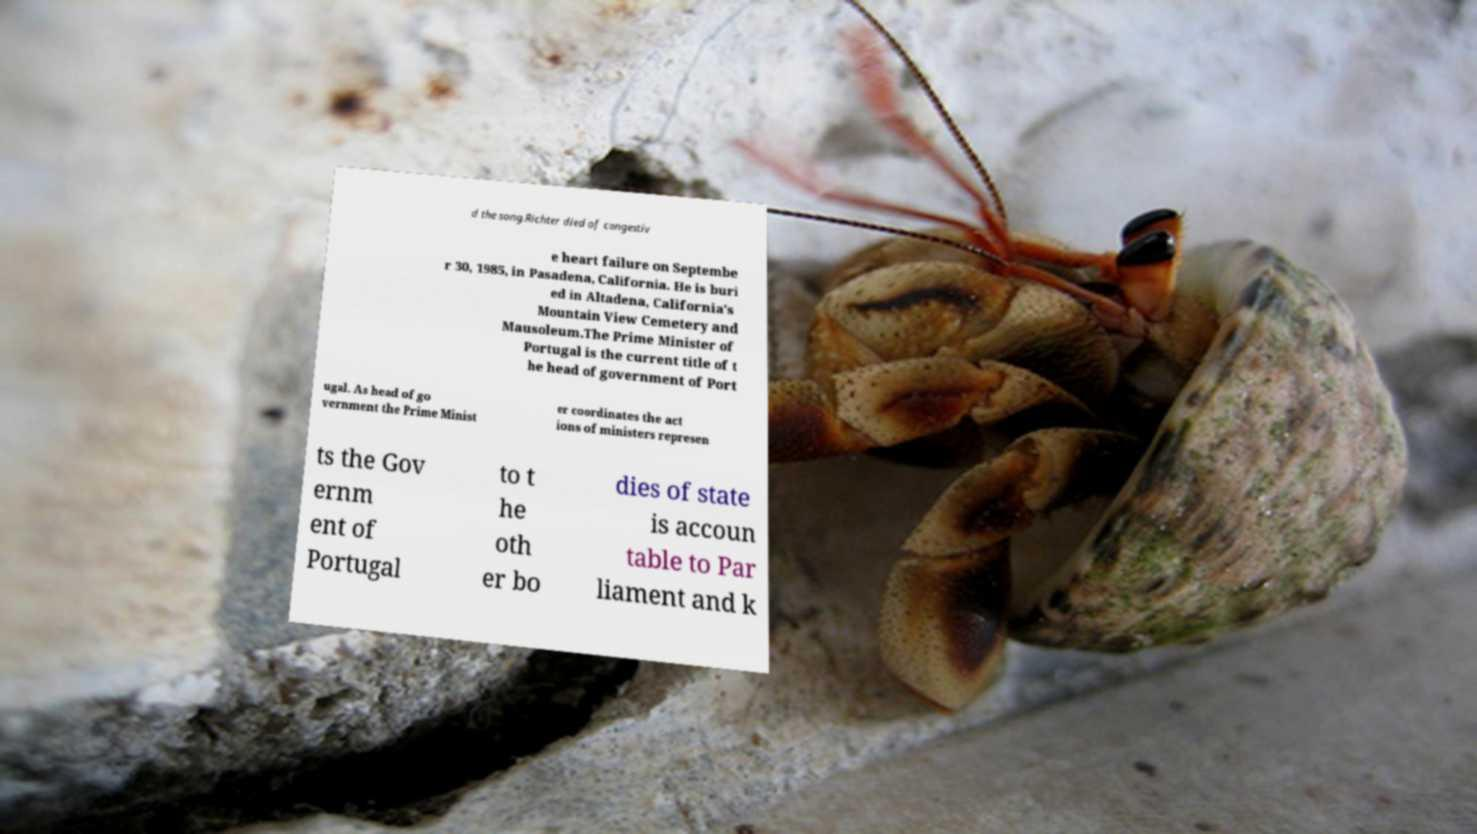For documentation purposes, I need the text within this image transcribed. Could you provide that? d the song.Richter died of congestiv e heart failure on Septembe r 30, 1985, in Pasadena, California. He is buri ed in Altadena, California's Mountain View Cemetery and Mausoleum.The Prime Minister of Portugal is the current title of t he head of government of Port ugal. As head of go vernment the Prime Minist er coordinates the act ions of ministers represen ts the Gov ernm ent of Portugal to t he oth er bo dies of state is accoun table to Par liament and k 